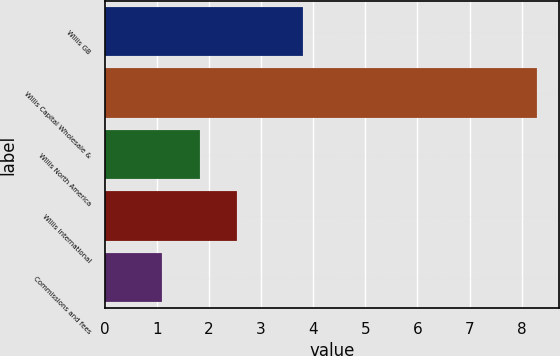<chart> <loc_0><loc_0><loc_500><loc_500><bar_chart><fcel>Willis GB<fcel>Willis Capital Wholesale &<fcel>Willis North America<fcel>Willis International<fcel>Commissions and fees<nl><fcel>3.8<fcel>8.3<fcel>1.82<fcel>2.54<fcel>1.1<nl></chart> 